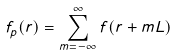Convert formula to latex. <formula><loc_0><loc_0><loc_500><loc_500>f _ { p } ( r ) = \sum _ { m = - \infty } ^ { \infty } f ( r + m L )</formula> 